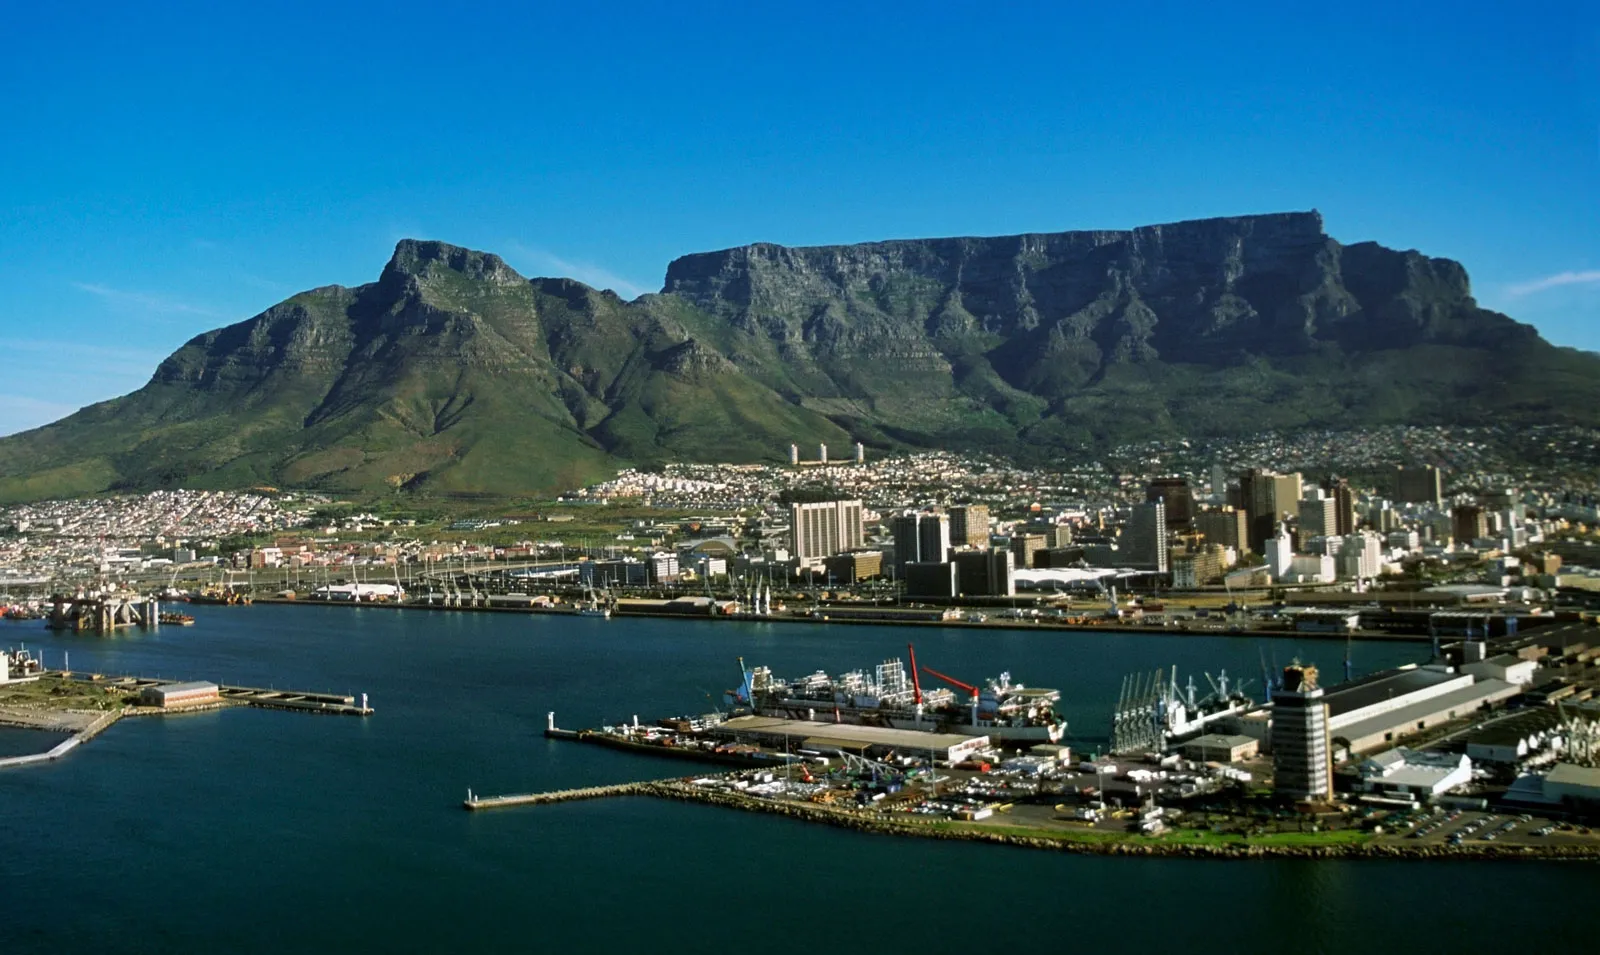Could you tell me about the unique vegetation that can be found on Table Mountain? The vegetation that crowns Table Mountain is part of the Cape Floral Region, also known as fynbos, which is a UNESCO World Heritage Site. This unique biome is renowned for its rich biodiversity and includes over 2,200 different species of plants, many of which are endemic and not found anywhere else. Table Mountain itself hosts several rare and endangered species. The area is particularly known for its proteas, ericas, and restios. The fynbos ecosystem is adapted to survive in the region's Mediterranean climate with its wet winters and dry summers, exhibiting a remarkable example of plant diversity and resilience. 